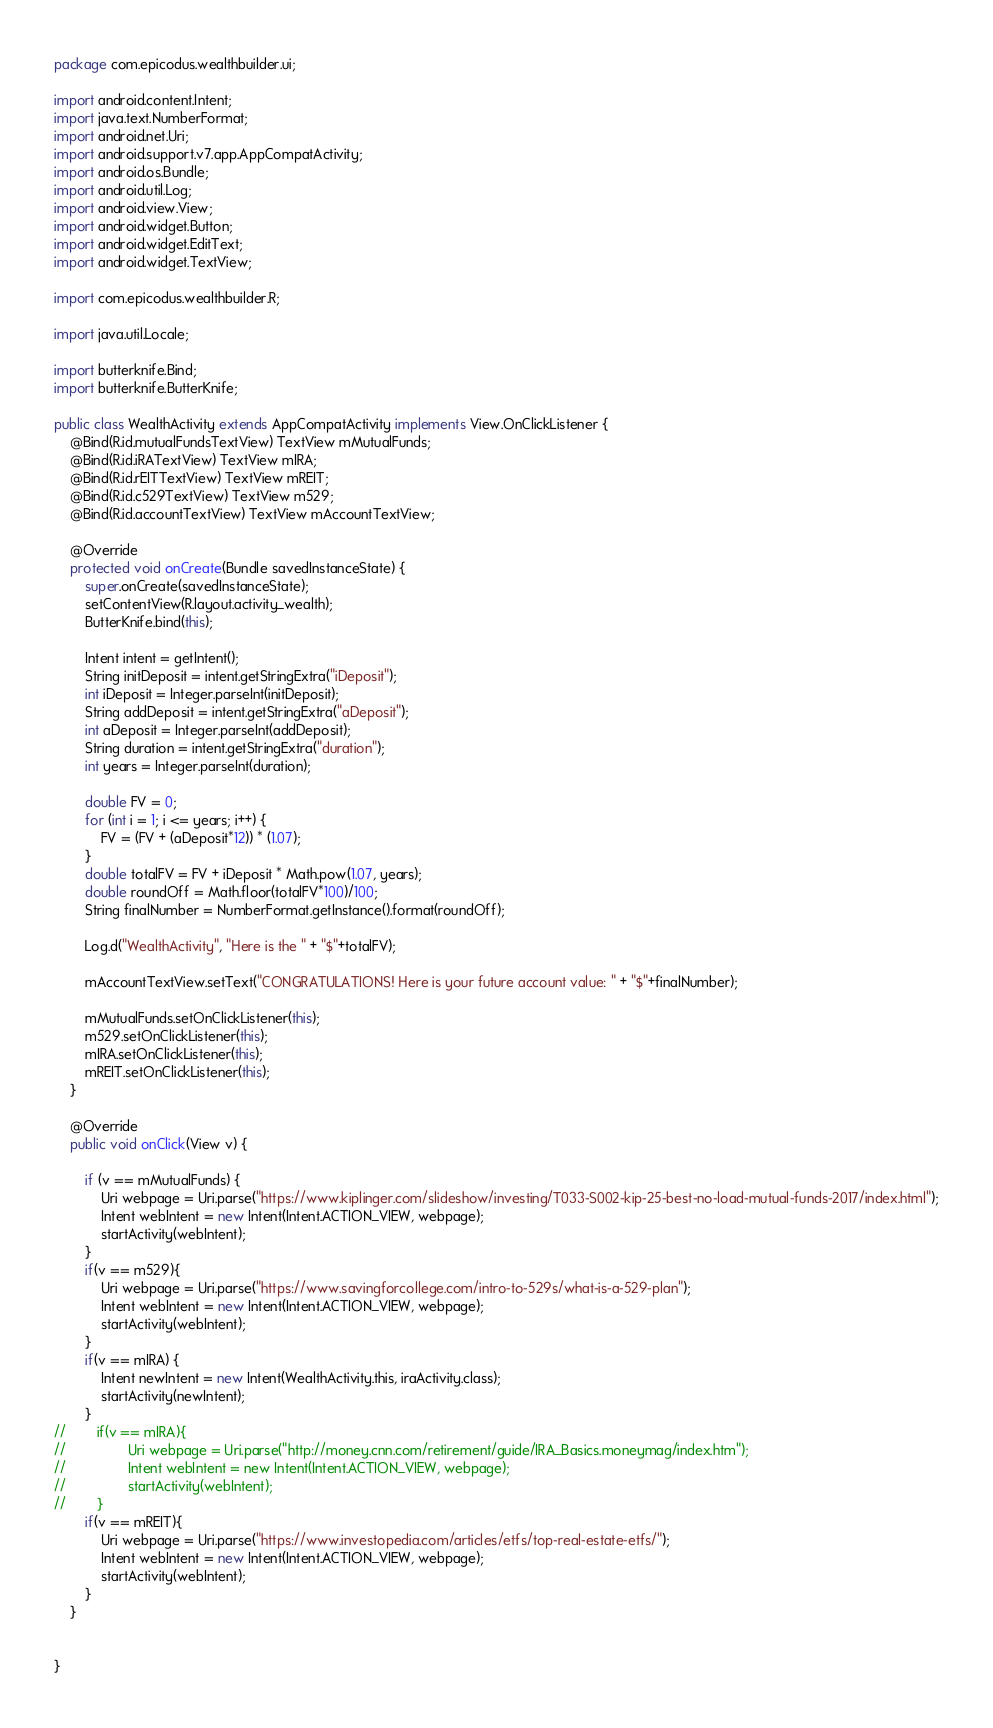<code> <loc_0><loc_0><loc_500><loc_500><_Java_>package com.epicodus.wealthbuilder.ui;

import android.content.Intent;
import java.text.NumberFormat;
import android.net.Uri;
import android.support.v7.app.AppCompatActivity;
import android.os.Bundle;
import android.util.Log;
import android.view.View;
import android.widget.Button;
import android.widget.EditText;
import android.widget.TextView;

import com.epicodus.wealthbuilder.R;

import java.util.Locale;

import butterknife.Bind;
import butterknife.ButterKnife;

public class WealthActivity extends AppCompatActivity implements View.OnClickListener {
    @Bind(R.id.mutualFundsTextView) TextView mMutualFunds;
    @Bind(R.id.iRATextView) TextView mIRA;
    @Bind(R.id.rEITTextView) TextView mREIT;
    @Bind(R.id.c529TextView) TextView m529;
    @Bind(R.id.accountTextView) TextView mAccountTextView;

    @Override
    protected void onCreate(Bundle savedInstanceState) {
        super.onCreate(savedInstanceState);
        setContentView(R.layout.activity_wealth);
        ButterKnife.bind(this);

        Intent intent = getIntent();
        String initDeposit = intent.getStringExtra("iDeposit");
        int iDeposit = Integer.parseInt(initDeposit);
        String addDeposit = intent.getStringExtra("aDeposit");
        int aDeposit = Integer.parseInt(addDeposit);
        String duration = intent.getStringExtra("duration");
        int years = Integer.parseInt(duration);

        double FV = 0;
        for (int i = 1; i <= years; i++) {
            FV = (FV + (aDeposit*12)) * (1.07);
        }
        double totalFV = FV + iDeposit * Math.pow(1.07, years);
        double roundOff = Math.floor(totalFV*100)/100;
        String finalNumber = NumberFormat.getInstance().format(roundOff);

        Log.d("WealthActivity", "Here is the " + "$"+totalFV);

        mAccountTextView.setText("CONGRATULATIONS! Here is your future account value: " + "$"+finalNumber);

        mMutualFunds.setOnClickListener(this);
        m529.setOnClickListener(this);
        mIRA.setOnClickListener(this);
        mREIT.setOnClickListener(this);
    }

    @Override
    public void onClick(View v) {

        if (v == mMutualFunds) {
            Uri webpage = Uri.parse("https://www.kiplinger.com/slideshow/investing/T033-S002-kip-25-best-no-load-mutual-funds-2017/index.html");
            Intent webIntent = new Intent(Intent.ACTION_VIEW, webpage);
            startActivity(webIntent);
        }
        if(v == m529){
            Uri webpage = Uri.parse("https://www.savingforcollege.com/intro-to-529s/what-is-a-529-plan");
            Intent webIntent = new Intent(Intent.ACTION_VIEW, webpage);
            startActivity(webIntent);
        }
        if(v == mIRA) {
            Intent newIntent = new Intent(WealthActivity.this, iraActivity.class);
            startActivity(newIntent);
        }
//        if(v == mIRA){
//                Uri webpage = Uri.parse("http://money.cnn.com/retirement/guide/IRA_Basics.moneymag/index.htm");
//                Intent webIntent = new Intent(Intent.ACTION_VIEW, webpage);
//                startActivity(webIntent);
//        }
        if(v == mREIT){
            Uri webpage = Uri.parse("https://www.investopedia.com/articles/etfs/top-real-estate-etfs/");
            Intent webIntent = new Intent(Intent.ACTION_VIEW, webpage);
            startActivity(webIntent);
        }
    }


}
</code> 